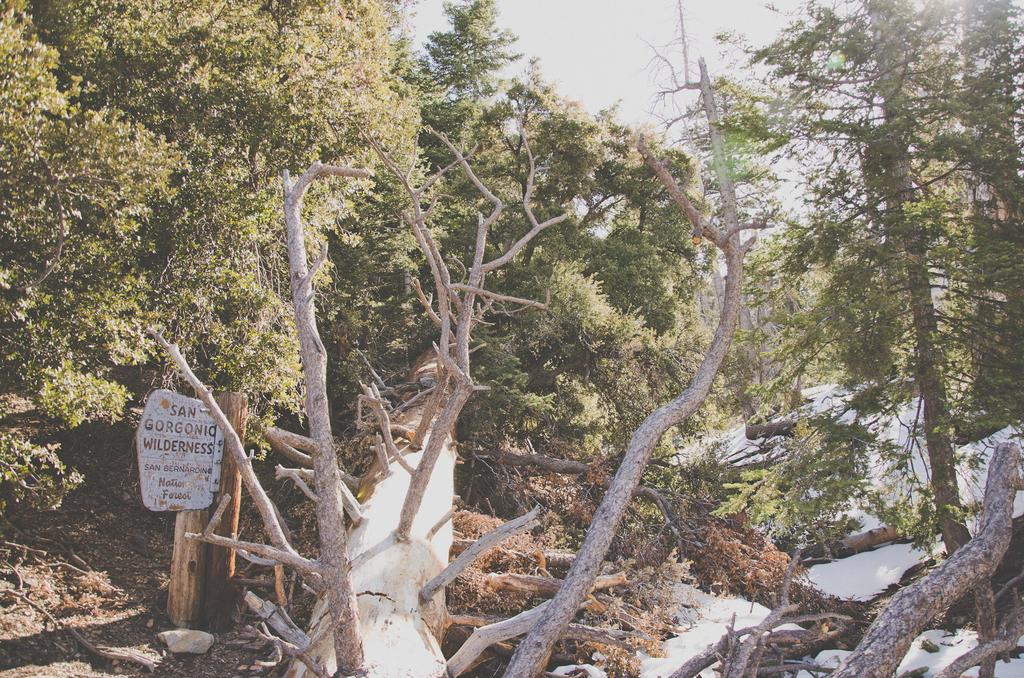What type of object can be seen in the image made of wood? There is a wooden log in the image. What other natural elements are present in the image? There are trees in the image. What can be seen in the background of the image? The sky is visible in the image. What type of sports equipment is in the image? There is a snowboard in the image. Is there any text or design on the snowboard? Yes, there is text on the snowboard. What type of reaction does the hen have when it sees the wooden log in the image? There is no hen present in the image, so it is not possible to determine its reaction to the wooden log. 